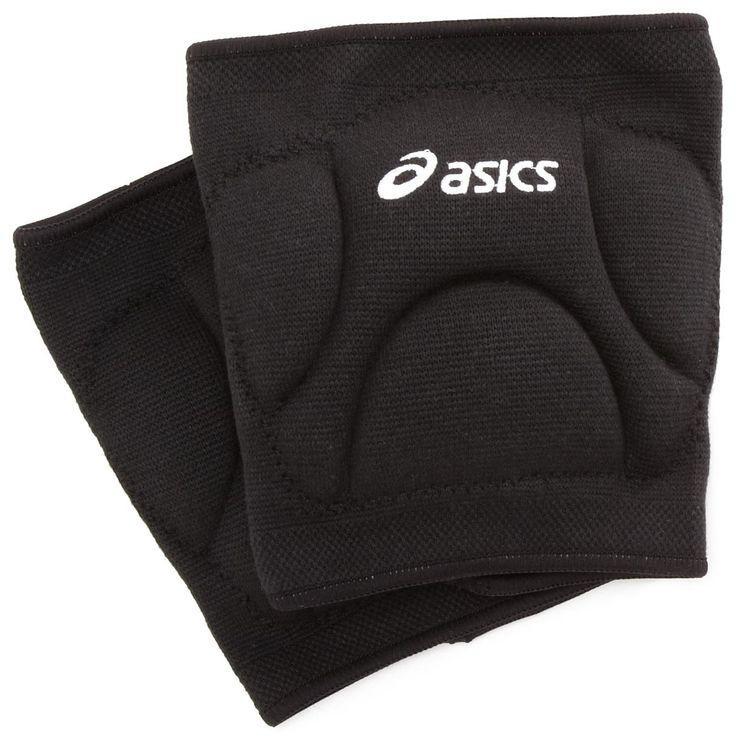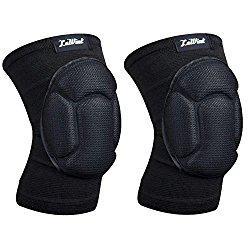The first image is the image on the left, the second image is the image on the right. Analyze the images presented: Is the assertion "At least one set of knee pads is green." valid? Answer yes or no. No. 